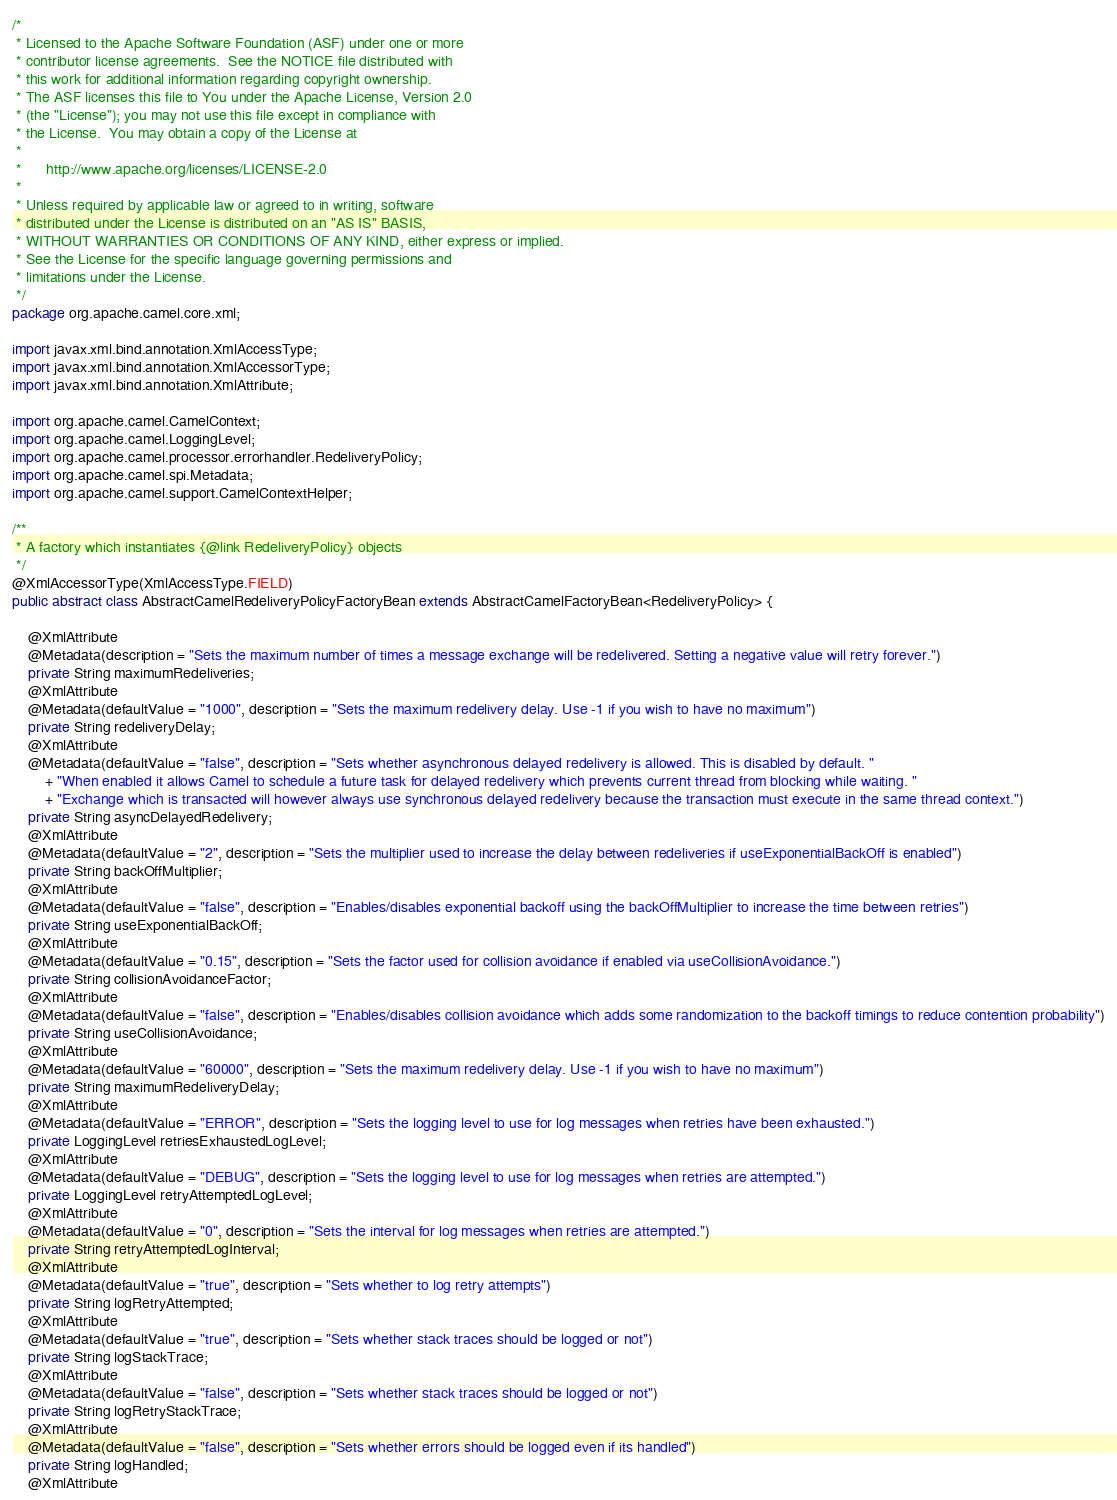<code> <loc_0><loc_0><loc_500><loc_500><_Java_>/*
 * Licensed to the Apache Software Foundation (ASF) under one or more
 * contributor license agreements.  See the NOTICE file distributed with
 * this work for additional information regarding copyright ownership.
 * The ASF licenses this file to You under the Apache License, Version 2.0
 * (the "License"); you may not use this file except in compliance with
 * the License.  You may obtain a copy of the License at
 *
 *      http://www.apache.org/licenses/LICENSE-2.0
 *
 * Unless required by applicable law or agreed to in writing, software
 * distributed under the License is distributed on an "AS IS" BASIS,
 * WITHOUT WARRANTIES OR CONDITIONS OF ANY KIND, either express or implied.
 * See the License for the specific language governing permissions and
 * limitations under the License.
 */
package org.apache.camel.core.xml;

import javax.xml.bind.annotation.XmlAccessType;
import javax.xml.bind.annotation.XmlAccessorType;
import javax.xml.bind.annotation.XmlAttribute;

import org.apache.camel.CamelContext;
import org.apache.camel.LoggingLevel;
import org.apache.camel.processor.errorhandler.RedeliveryPolicy;
import org.apache.camel.spi.Metadata;
import org.apache.camel.support.CamelContextHelper;

/**
 * A factory which instantiates {@link RedeliveryPolicy} objects
 */
@XmlAccessorType(XmlAccessType.FIELD)
public abstract class AbstractCamelRedeliveryPolicyFactoryBean extends AbstractCamelFactoryBean<RedeliveryPolicy> {

    @XmlAttribute
    @Metadata(description = "Sets the maximum number of times a message exchange will be redelivered. Setting a negative value will retry forever.")
    private String maximumRedeliveries;
    @XmlAttribute
    @Metadata(defaultValue = "1000", description = "Sets the maximum redelivery delay. Use -1 if you wish to have no maximum")
    private String redeliveryDelay;
    @XmlAttribute
    @Metadata(defaultValue = "false", description = "Sets whether asynchronous delayed redelivery is allowed. This is disabled by default. "
        + "When enabled it allows Camel to schedule a future task for delayed redelivery which prevents current thread from blocking while waiting. "
        + "Exchange which is transacted will however always use synchronous delayed redelivery because the transaction must execute in the same thread context.")
    private String asyncDelayedRedelivery;
    @XmlAttribute
    @Metadata(defaultValue = "2", description = "Sets the multiplier used to increase the delay between redeliveries if useExponentialBackOff is enabled")
    private String backOffMultiplier;
    @XmlAttribute
    @Metadata(defaultValue = "false", description = "Enables/disables exponential backoff using the backOffMultiplier to increase the time between retries")
    private String useExponentialBackOff;
    @XmlAttribute
    @Metadata(defaultValue = "0.15", description = "Sets the factor used for collision avoidance if enabled via useCollisionAvoidance.")
    private String collisionAvoidanceFactor;
    @XmlAttribute
    @Metadata(defaultValue = "false", description = "Enables/disables collision avoidance which adds some randomization to the backoff timings to reduce contention probability")
    private String useCollisionAvoidance;
    @XmlAttribute
    @Metadata(defaultValue = "60000", description = "Sets the maximum redelivery delay. Use -1 if you wish to have no maximum")
    private String maximumRedeliveryDelay;
    @XmlAttribute
    @Metadata(defaultValue = "ERROR", description = "Sets the logging level to use for log messages when retries have been exhausted.")
    private LoggingLevel retriesExhaustedLogLevel;
    @XmlAttribute
    @Metadata(defaultValue = "DEBUG", description = "Sets the logging level to use for log messages when retries are attempted.")
    private LoggingLevel retryAttemptedLogLevel;
    @XmlAttribute
    @Metadata(defaultValue = "0", description = "Sets the interval for log messages when retries are attempted.")
    private String retryAttemptedLogInterval;
    @XmlAttribute
    @Metadata(defaultValue = "true", description = "Sets whether to log retry attempts")
    private String logRetryAttempted;
    @XmlAttribute
    @Metadata(defaultValue = "true", description = "Sets whether stack traces should be logged or not")
    private String logStackTrace;
    @XmlAttribute
    @Metadata(defaultValue = "false", description = "Sets whether stack traces should be logged or not")
    private String logRetryStackTrace;
    @XmlAttribute
    @Metadata(defaultValue = "false", description = "Sets whether errors should be logged even if its handled")
    private String logHandled;
    @XmlAttribute</code> 